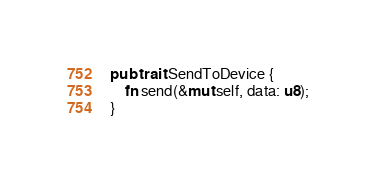Convert code to text. <code><loc_0><loc_0><loc_500><loc_500><_Rust_>pub trait SendToDevice {
    fn send(&mut self, data: u8);
}
</code> 